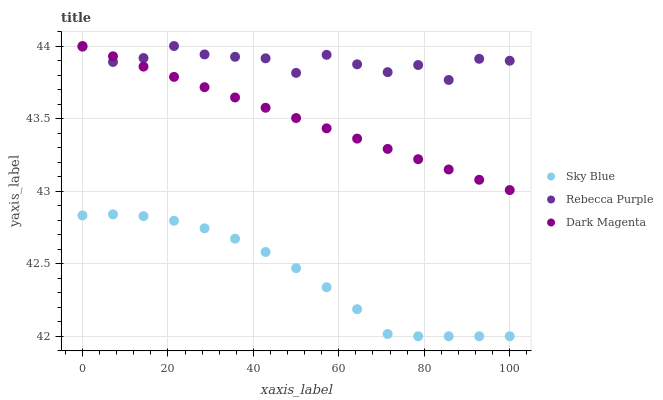Does Sky Blue have the minimum area under the curve?
Answer yes or no. Yes. Does Rebecca Purple have the maximum area under the curve?
Answer yes or no. Yes. Does Dark Magenta have the minimum area under the curve?
Answer yes or no. No. Does Dark Magenta have the maximum area under the curve?
Answer yes or no. No. Is Dark Magenta the smoothest?
Answer yes or no. Yes. Is Rebecca Purple the roughest?
Answer yes or no. Yes. Is Rebecca Purple the smoothest?
Answer yes or no. No. Is Dark Magenta the roughest?
Answer yes or no. No. Does Sky Blue have the lowest value?
Answer yes or no. Yes. Does Dark Magenta have the lowest value?
Answer yes or no. No. Does Dark Magenta have the highest value?
Answer yes or no. Yes. Is Sky Blue less than Dark Magenta?
Answer yes or no. Yes. Is Dark Magenta greater than Sky Blue?
Answer yes or no. Yes. Does Dark Magenta intersect Rebecca Purple?
Answer yes or no. Yes. Is Dark Magenta less than Rebecca Purple?
Answer yes or no. No. Is Dark Magenta greater than Rebecca Purple?
Answer yes or no. No. Does Sky Blue intersect Dark Magenta?
Answer yes or no. No. 